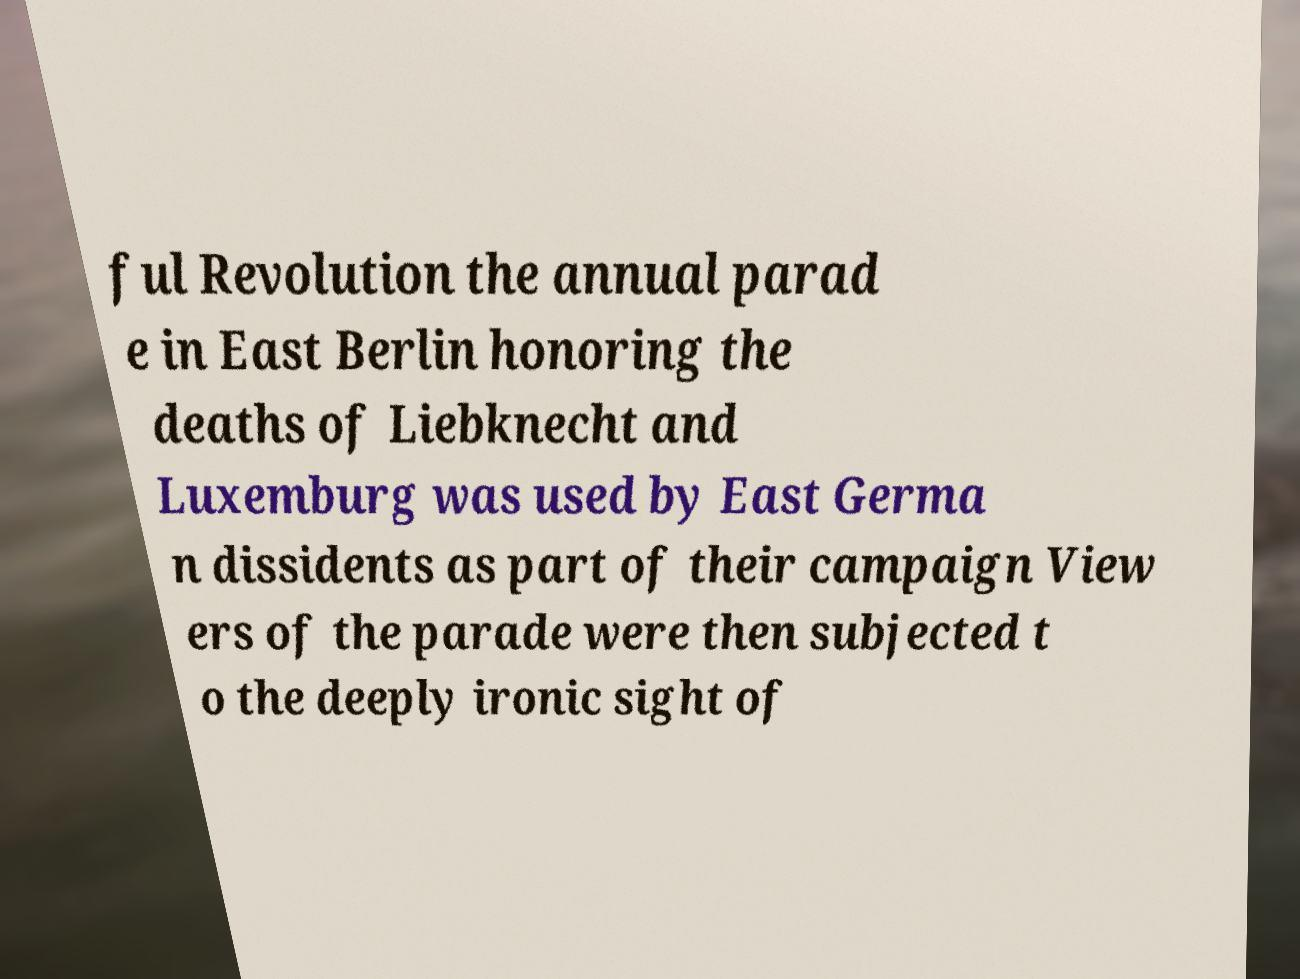Can you read and provide the text displayed in the image?This photo seems to have some interesting text. Can you extract and type it out for me? ful Revolution the annual parad e in East Berlin honoring the deaths of Liebknecht and Luxemburg was used by East Germa n dissidents as part of their campaign View ers of the parade were then subjected t o the deeply ironic sight of 